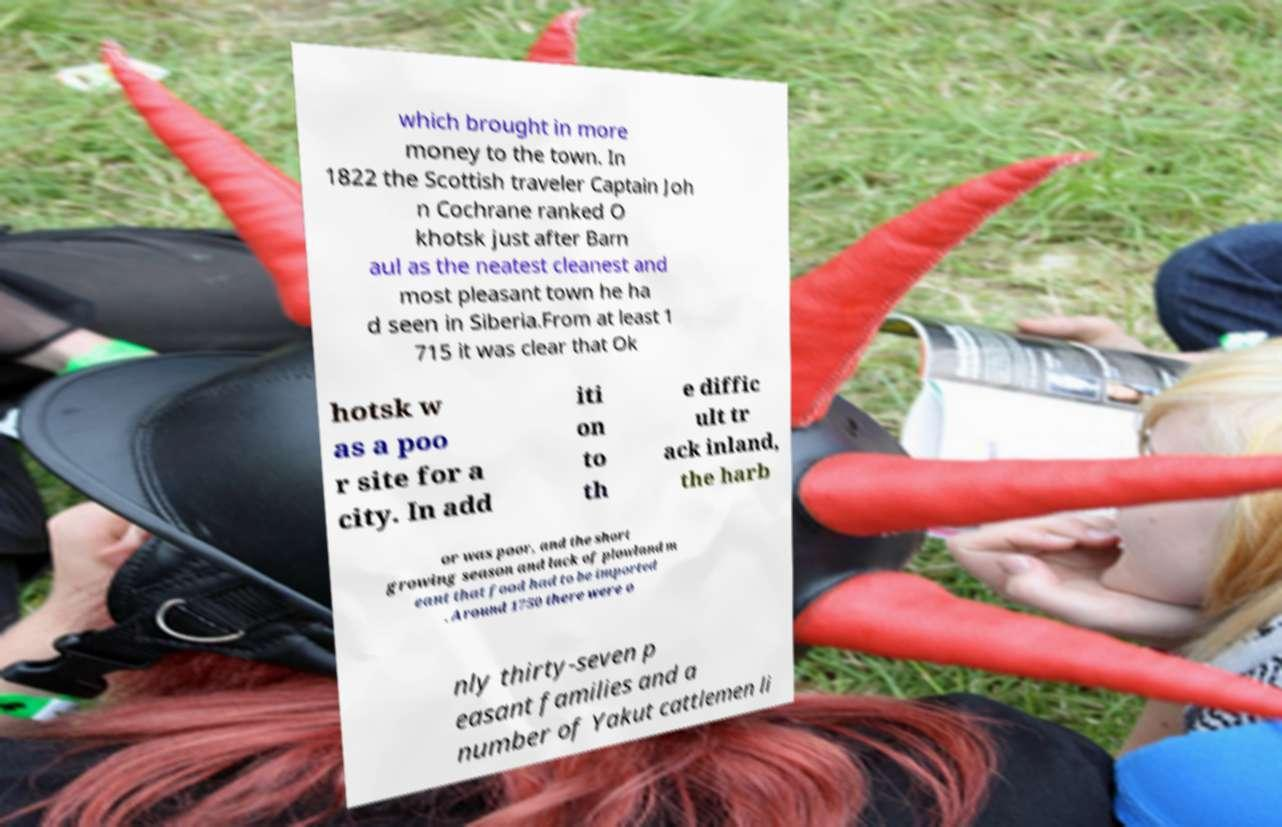Can you accurately transcribe the text from the provided image for me? which brought in more money to the town. In 1822 the Scottish traveler Captain Joh n Cochrane ranked O khotsk just after Barn aul as the neatest cleanest and most pleasant town he ha d seen in Siberia.From at least 1 715 it was clear that Ok hotsk w as a poo r site for a city. In add iti on to th e diffic ult tr ack inland, the harb or was poor, and the short growing season and lack of plowland m eant that food had to be imported . Around 1750 there were o nly thirty-seven p easant families and a number of Yakut cattlemen li 